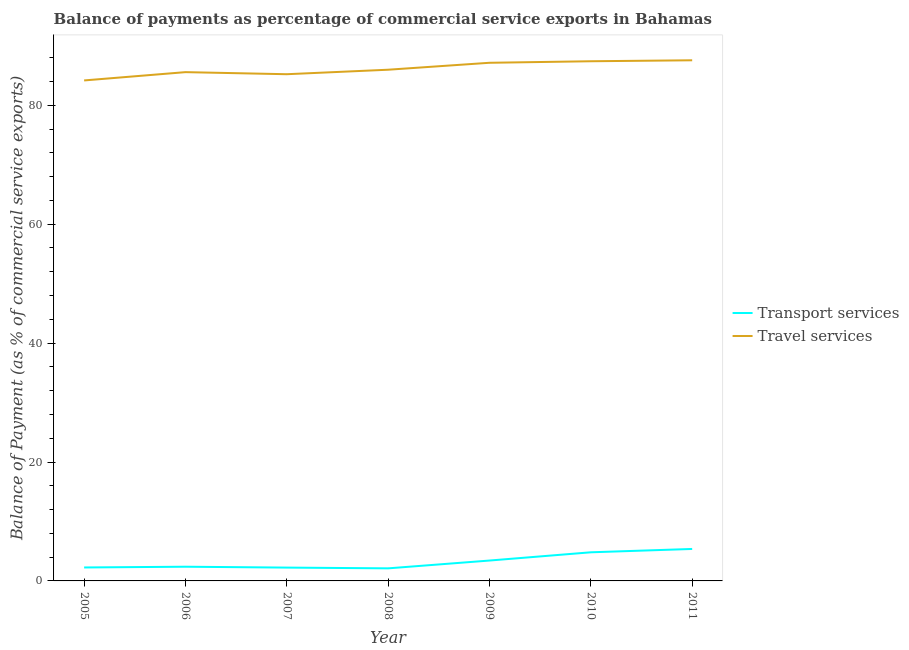Is the number of lines equal to the number of legend labels?
Offer a terse response. Yes. What is the balance of payments of transport services in 2009?
Offer a terse response. 3.43. Across all years, what is the maximum balance of payments of travel services?
Provide a succinct answer. 87.57. Across all years, what is the minimum balance of payments of travel services?
Give a very brief answer. 84.18. What is the total balance of payments of transport services in the graph?
Keep it short and to the point. 22.63. What is the difference between the balance of payments of travel services in 2009 and that in 2010?
Give a very brief answer. -0.26. What is the difference between the balance of payments of transport services in 2006 and the balance of payments of travel services in 2009?
Ensure brevity in your answer.  -84.76. What is the average balance of payments of travel services per year?
Give a very brief answer. 86.15. In the year 2008, what is the difference between the balance of payments of transport services and balance of payments of travel services?
Ensure brevity in your answer.  -83.86. What is the ratio of the balance of payments of transport services in 2008 to that in 2010?
Provide a succinct answer. 0.44. Is the balance of payments of travel services in 2006 less than that in 2007?
Provide a succinct answer. No. Is the difference between the balance of payments of transport services in 2007 and 2009 greater than the difference between the balance of payments of travel services in 2007 and 2009?
Give a very brief answer. Yes. What is the difference between the highest and the second highest balance of payments of transport services?
Provide a succinct answer. 0.56. What is the difference between the highest and the lowest balance of payments of transport services?
Offer a terse response. 3.26. In how many years, is the balance of payments of transport services greater than the average balance of payments of transport services taken over all years?
Provide a short and direct response. 3. Is the sum of the balance of payments of travel services in 2007 and 2008 greater than the maximum balance of payments of transport services across all years?
Your answer should be very brief. Yes. Is the balance of payments of transport services strictly less than the balance of payments of travel services over the years?
Keep it short and to the point. Yes. How many lines are there?
Your answer should be compact. 2. How many years are there in the graph?
Provide a short and direct response. 7. What is the difference between two consecutive major ticks on the Y-axis?
Make the answer very short. 20. Does the graph contain grids?
Ensure brevity in your answer.  No. Where does the legend appear in the graph?
Your answer should be very brief. Center right. How are the legend labels stacked?
Offer a very short reply. Vertical. What is the title of the graph?
Keep it short and to the point. Balance of payments as percentage of commercial service exports in Bahamas. What is the label or title of the X-axis?
Provide a short and direct response. Year. What is the label or title of the Y-axis?
Offer a very short reply. Balance of Payment (as % of commercial service exports). What is the Balance of Payment (as % of commercial service exports) of Transport services in 2005?
Provide a succinct answer. 2.26. What is the Balance of Payment (as % of commercial service exports) of Travel services in 2005?
Offer a terse response. 84.18. What is the Balance of Payment (as % of commercial service exports) of Transport services in 2006?
Your response must be concise. 2.39. What is the Balance of Payment (as % of commercial service exports) of Travel services in 2006?
Offer a very short reply. 85.57. What is the Balance of Payment (as % of commercial service exports) in Transport services in 2007?
Ensure brevity in your answer.  2.24. What is the Balance of Payment (as % of commercial service exports) of Travel services in 2007?
Provide a succinct answer. 85.22. What is the Balance of Payment (as % of commercial service exports) in Transport services in 2008?
Your answer should be very brief. 2.11. What is the Balance of Payment (as % of commercial service exports) in Travel services in 2008?
Offer a terse response. 85.98. What is the Balance of Payment (as % of commercial service exports) of Transport services in 2009?
Offer a terse response. 3.43. What is the Balance of Payment (as % of commercial service exports) of Travel services in 2009?
Give a very brief answer. 87.15. What is the Balance of Payment (as % of commercial service exports) in Transport services in 2010?
Make the answer very short. 4.81. What is the Balance of Payment (as % of commercial service exports) in Travel services in 2010?
Offer a very short reply. 87.4. What is the Balance of Payment (as % of commercial service exports) in Transport services in 2011?
Your answer should be compact. 5.38. What is the Balance of Payment (as % of commercial service exports) of Travel services in 2011?
Your answer should be very brief. 87.57. Across all years, what is the maximum Balance of Payment (as % of commercial service exports) in Transport services?
Your response must be concise. 5.38. Across all years, what is the maximum Balance of Payment (as % of commercial service exports) in Travel services?
Keep it short and to the point. 87.57. Across all years, what is the minimum Balance of Payment (as % of commercial service exports) in Transport services?
Offer a very short reply. 2.11. Across all years, what is the minimum Balance of Payment (as % of commercial service exports) in Travel services?
Provide a succinct answer. 84.18. What is the total Balance of Payment (as % of commercial service exports) in Transport services in the graph?
Offer a very short reply. 22.63. What is the total Balance of Payment (as % of commercial service exports) of Travel services in the graph?
Provide a short and direct response. 603.07. What is the difference between the Balance of Payment (as % of commercial service exports) of Transport services in 2005 and that in 2006?
Make the answer very short. -0.13. What is the difference between the Balance of Payment (as % of commercial service exports) of Travel services in 2005 and that in 2006?
Ensure brevity in your answer.  -1.39. What is the difference between the Balance of Payment (as % of commercial service exports) in Transport services in 2005 and that in 2007?
Offer a terse response. 0.02. What is the difference between the Balance of Payment (as % of commercial service exports) in Travel services in 2005 and that in 2007?
Make the answer very short. -1.05. What is the difference between the Balance of Payment (as % of commercial service exports) of Transport services in 2005 and that in 2008?
Provide a succinct answer. 0.15. What is the difference between the Balance of Payment (as % of commercial service exports) in Travel services in 2005 and that in 2008?
Offer a very short reply. -1.8. What is the difference between the Balance of Payment (as % of commercial service exports) of Transport services in 2005 and that in 2009?
Offer a very short reply. -1.17. What is the difference between the Balance of Payment (as % of commercial service exports) of Travel services in 2005 and that in 2009?
Your answer should be very brief. -2.97. What is the difference between the Balance of Payment (as % of commercial service exports) of Transport services in 2005 and that in 2010?
Your answer should be very brief. -2.55. What is the difference between the Balance of Payment (as % of commercial service exports) in Travel services in 2005 and that in 2010?
Provide a succinct answer. -3.23. What is the difference between the Balance of Payment (as % of commercial service exports) of Transport services in 2005 and that in 2011?
Offer a terse response. -3.12. What is the difference between the Balance of Payment (as % of commercial service exports) of Travel services in 2005 and that in 2011?
Ensure brevity in your answer.  -3.39. What is the difference between the Balance of Payment (as % of commercial service exports) of Transport services in 2006 and that in 2007?
Make the answer very short. 0.15. What is the difference between the Balance of Payment (as % of commercial service exports) of Travel services in 2006 and that in 2007?
Give a very brief answer. 0.35. What is the difference between the Balance of Payment (as % of commercial service exports) of Transport services in 2006 and that in 2008?
Offer a very short reply. 0.27. What is the difference between the Balance of Payment (as % of commercial service exports) in Travel services in 2006 and that in 2008?
Give a very brief answer. -0.41. What is the difference between the Balance of Payment (as % of commercial service exports) in Transport services in 2006 and that in 2009?
Your answer should be very brief. -1.04. What is the difference between the Balance of Payment (as % of commercial service exports) in Travel services in 2006 and that in 2009?
Ensure brevity in your answer.  -1.58. What is the difference between the Balance of Payment (as % of commercial service exports) in Transport services in 2006 and that in 2010?
Keep it short and to the point. -2.42. What is the difference between the Balance of Payment (as % of commercial service exports) of Travel services in 2006 and that in 2010?
Keep it short and to the point. -1.83. What is the difference between the Balance of Payment (as % of commercial service exports) of Transport services in 2006 and that in 2011?
Provide a succinct answer. -2.99. What is the difference between the Balance of Payment (as % of commercial service exports) of Travel services in 2006 and that in 2011?
Provide a succinct answer. -2. What is the difference between the Balance of Payment (as % of commercial service exports) of Transport services in 2007 and that in 2008?
Offer a very short reply. 0.13. What is the difference between the Balance of Payment (as % of commercial service exports) of Travel services in 2007 and that in 2008?
Offer a terse response. -0.76. What is the difference between the Balance of Payment (as % of commercial service exports) in Transport services in 2007 and that in 2009?
Your answer should be very brief. -1.19. What is the difference between the Balance of Payment (as % of commercial service exports) in Travel services in 2007 and that in 2009?
Keep it short and to the point. -1.92. What is the difference between the Balance of Payment (as % of commercial service exports) of Transport services in 2007 and that in 2010?
Offer a very short reply. -2.57. What is the difference between the Balance of Payment (as % of commercial service exports) of Travel services in 2007 and that in 2010?
Ensure brevity in your answer.  -2.18. What is the difference between the Balance of Payment (as % of commercial service exports) of Transport services in 2007 and that in 2011?
Your response must be concise. -3.14. What is the difference between the Balance of Payment (as % of commercial service exports) of Travel services in 2007 and that in 2011?
Your answer should be very brief. -2.34. What is the difference between the Balance of Payment (as % of commercial service exports) of Transport services in 2008 and that in 2009?
Give a very brief answer. -1.31. What is the difference between the Balance of Payment (as % of commercial service exports) of Travel services in 2008 and that in 2009?
Your response must be concise. -1.17. What is the difference between the Balance of Payment (as % of commercial service exports) of Transport services in 2008 and that in 2010?
Your answer should be compact. -2.7. What is the difference between the Balance of Payment (as % of commercial service exports) in Travel services in 2008 and that in 2010?
Give a very brief answer. -1.43. What is the difference between the Balance of Payment (as % of commercial service exports) in Transport services in 2008 and that in 2011?
Your answer should be very brief. -3.26. What is the difference between the Balance of Payment (as % of commercial service exports) of Travel services in 2008 and that in 2011?
Your answer should be compact. -1.59. What is the difference between the Balance of Payment (as % of commercial service exports) of Transport services in 2009 and that in 2010?
Offer a terse response. -1.39. What is the difference between the Balance of Payment (as % of commercial service exports) in Travel services in 2009 and that in 2010?
Offer a terse response. -0.26. What is the difference between the Balance of Payment (as % of commercial service exports) of Transport services in 2009 and that in 2011?
Provide a succinct answer. -1.95. What is the difference between the Balance of Payment (as % of commercial service exports) of Travel services in 2009 and that in 2011?
Your response must be concise. -0.42. What is the difference between the Balance of Payment (as % of commercial service exports) in Transport services in 2010 and that in 2011?
Keep it short and to the point. -0.56. What is the difference between the Balance of Payment (as % of commercial service exports) in Travel services in 2010 and that in 2011?
Offer a very short reply. -0.16. What is the difference between the Balance of Payment (as % of commercial service exports) in Transport services in 2005 and the Balance of Payment (as % of commercial service exports) in Travel services in 2006?
Provide a succinct answer. -83.31. What is the difference between the Balance of Payment (as % of commercial service exports) in Transport services in 2005 and the Balance of Payment (as % of commercial service exports) in Travel services in 2007?
Provide a short and direct response. -82.96. What is the difference between the Balance of Payment (as % of commercial service exports) of Transport services in 2005 and the Balance of Payment (as % of commercial service exports) of Travel services in 2008?
Your answer should be compact. -83.72. What is the difference between the Balance of Payment (as % of commercial service exports) in Transport services in 2005 and the Balance of Payment (as % of commercial service exports) in Travel services in 2009?
Offer a very short reply. -84.88. What is the difference between the Balance of Payment (as % of commercial service exports) of Transport services in 2005 and the Balance of Payment (as % of commercial service exports) of Travel services in 2010?
Provide a succinct answer. -85.14. What is the difference between the Balance of Payment (as % of commercial service exports) of Transport services in 2005 and the Balance of Payment (as % of commercial service exports) of Travel services in 2011?
Make the answer very short. -85.3. What is the difference between the Balance of Payment (as % of commercial service exports) of Transport services in 2006 and the Balance of Payment (as % of commercial service exports) of Travel services in 2007?
Provide a succinct answer. -82.83. What is the difference between the Balance of Payment (as % of commercial service exports) in Transport services in 2006 and the Balance of Payment (as % of commercial service exports) in Travel services in 2008?
Provide a short and direct response. -83.59. What is the difference between the Balance of Payment (as % of commercial service exports) in Transport services in 2006 and the Balance of Payment (as % of commercial service exports) in Travel services in 2009?
Your answer should be compact. -84.76. What is the difference between the Balance of Payment (as % of commercial service exports) in Transport services in 2006 and the Balance of Payment (as % of commercial service exports) in Travel services in 2010?
Provide a short and direct response. -85.02. What is the difference between the Balance of Payment (as % of commercial service exports) of Transport services in 2006 and the Balance of Payment (as % of commercial service exports) of Travel services in 2011?
Give a very brief answer. -85.18. What is the difference between the Balance of Payment (as % of commercial service exports) in Transport services in 2007 and the Balance of Payment (as % of commercial service exports) in Travel services in 2008?
Provide a succinct answer. -83.74. What is the difference between the Balance of Payment (as % of commercial service exports) in Transport services in 2007 and the Balance of Payment (as % of commercial service exports) in Travel services in 2009?
Give a very brief answer. -84.91. What is the difference between the Balance of Payment (as % of commercial service exports) of Transport services in 2007 and the Balance of Payment (as % of commercial service exports) of Travel services in 2010?
Keep it short and to the point. -85.16. What is the difference between the Balance of Payment (as % of commercial service exports) in Transport services in 2007 and the Balance of Payment (as % of commercial service exports) in Travel services in 2011?
Ensure brevity in your answer.  -85.32. What is the difference between the Balance of Payment (as % of commercial service exports) in Transport services in 2008 and the Balance of Payment (as % of commercial service exports) in Travel services in 2009?
Keep it short and to the point. -85.03. What is the difference between the Balance of Payment (as % of commercial service exports) in Transport services in 2008 and the Balance of Payment (as % of commercial service exports) in Travel services in 2010?
Keep it short and to the point. -85.29. What is the difference between the Balance of Payment (as % of commercial service exports) in Transport services in 2008 and the Balance of Payment (as % of commercial service exports) in Travel services in 2011?
Provide a short and direct response. -85.45. What is the difference between the Balance of Payment (as % of commercial service exports) in Transport services in 2009 and the Balance of Payment (as % of commercial service exports) in Travel services in 2010?
Your answer should be very brief. -83.98. What is the difference between the Balance of Payment (as % of commercial service exports) of Transport services in 2009 and the Balance of Payment (as % of commercial service exports) of Travel services in 2011?
Offer a very short reply. -84.14. What is the difference between the Balance of Payment (as % of commercial service exports) of Transport services in 2010 and the Balance of Payment (as % of commercial service exports) of Travel services in 2011?
Provide a short and direct response. -82.75. What is the average Balance of Payment (as % of commercial service exports) in Transport services per year?
Ensure brevity in your answer.  3.23. What is the average Balance of Payment (as % of commercial service exports) in Travel services per year?
Keep it short and to the point. 86.15. In the year 2005, what is the difference between the Balance of Payment (as % of commercial service exports) in Transport services and Balance of Payment (as % of commercial service exports) in Travel services?
Provide a succinct answer. -81.91. In the year 2006, what is the difference between the Balance of Payment (as % of commercial service exports) in Transport services and Balance of Payment (as % of commercial service exports) in Travel services?
Your answer should be very brief. -83.18. In the year 2007, what is the difference between the Balance of Payment (as % of commercial service exports) in Transport services and Balance of Payment (as % of commercial service exports) in Travel services?
Provide a succinct answer. -82.98. In the year 2008, what is the difference between the Balance of Payment (as % of commercial service exports) of Transport services and Balance of Payment (as % of commercial service exports) of Travel services?
Your answer should be compact. -83.86. In the year 2009, what is the difference between the Balance of Payment (as % of commercial service exports) of Transport services and Balance of Payment (as % of commercial service exports) of Travel services?
Make the answer very short. -83.72. In the year 2010, what is the difference between the Balance of Payment (as % of commercial service exports) of Transport services and Balance of Payment (as % of commercial service exports) of Travel services?
Provide a short and direct response. -82.59. In the year 2011, what is the difference between the Balance of Payment (as % of commercial service exports) of Transport services and Balance of Payment (as % of commercial service exports) of Travel services?
Provide a succinct answer. -82.19. What is the ratio of the Balance of Payment (as % of commercial service exports) in Transport services in 2005 to that in 2006?
Make the answer very short. 0.95. What is the ratio of the Balance of Payment (as % of commercial service exports) of Travel services in 2005 to that in 2006?
Offer a very short reply. 0.98. What is the ratio of the Balance of Payment (as % of commercial service exports) in Transport services in 2005 to that in 2007?
Keep it short and to the point. 1.01. What is the ratio of the Balance of Payment (as % of commercial service exports) of Transport services in 2005 to that in 2008?
Make the answer very short. 1.07. What is the ratio of the Balance of Payment (as % of commercial service exports) in Transport services in 2005 to that in 2009?
Ensure brevity in your answer.  0.66. What is the ratio of the Balance of Payment (as % of commercial service exports) of Travel services in 2005 to that in 2009?
Provide a short and direct response. 0.97. What is the ratio of the Balance of Payment (as % of commercial service exports) in Transport services in 2005 to that in 2010?
Your answer should be compact. 0.47. What is the ratio of the Balance of Payment (as % of commercial service exports) in Travel services in 2005 to that in 2010?
Keep it short and to the point. 0.96. What is the ratio of the Balance of Payment (as % of commercial service exports) of Transport services in 2005 to that in 2011?
Your answer should be compact. 0.42. What is the ratio of the Balance of Payment (as % of commercial service exports) in Travel services in 2005 to that in 2011?
Provide a succinct answer. 0.96. What is the ratio of the Balance of Payment (as % of commercial service exports) in Transport services in 2006 to that in 2007?
Make the answer very short. 1.07. What is the ratio of the Balance of Payment (as % of commercial service exports) of Transport services in 2006 to that in 2008?
Make the answer very short. 1.13. What is the ratio of the Balance of Payment (as % of commercial service exports) in Travel services in 2006 to that in 2008?
Your answer should be very brief. 1. What is the ratio of the Balance of Payment (as % of commercial service exports) in Transport services in 2006 to that in 2009?
Make the answer very short. 0.7. What is the ratio of the Balance of Payment (as % of commercial service exports) in Travel services in 2006 to that in 2009?
Your response must be concise. 0.98. What is the ratio of the Balance of Payment (as % of commercial service exports) in Transport services in 2006 to that in 2010?
Ensure brevity in your answer.  0.5. What is the ratio of the Balance of Payment (as % of commercial service exports) of Transport services in 2006 to that in 2011?
Ensure brevity in your answer.  0.44. What is the ratio of the Balance of Payment (as % of commercial service exports) of Travel services in 2006 to that in 2011?
Your answer should be very brief. 0.98. What is the ratio of the Balance of Payment (as % of commercial service exports) in Transport services in 2007 to that in 2008?
Ensure brevity in your answer.  1.06. What is the ratio of the Balance of Payment (as % of commercial service exports) of Transport services in 2007 to that in 2009?
Give a very brief answer. 0.65. What is the ratio of the Balance of Payment (as % of commercial service exports) in Travel services in 2007 to that in 2009?
Offer a terse response. 0.98. What is the ratio of the Balance of Payment (as % of commercial service exports) of Transport services in 2007 to that in 2010?
Your answer should be very brief. 0.47. What is the ratio of the Balance of Payment (as % of commercial service exports) of Transport services in 2007 to that in 2011?
Keep it short and to the point. 0.42. What is the ratio of the Balance of Payment (as % of commercial service exports) of Travel services in 2007 to that in 2011?
Make the answer very short. 0.97. What is the ratio of the Balance of Payment (as % of commercial service exports) of Transport services in 2008 to that in 2009?
Your answer should be very brief. 0.62. What is the ratio of the Balance of Payment (as % of commercial service exports) in Travel services in 2008 to that in 2009?
Offer a very short reply. 0.99. What is the ratio of the Balance of Payment (as % of commercial service exports) in Transport services in 2008 to that in 2010?
Offer a very short reply. 0.44. What is the ratio of the Balance of Payment (as % of commercial service exports) of Travel services in 2008 to that in 2010?
Provide a succinct answer. 0.98. What is the ratio of the Balance of Payment (as % of commercial service exports) of Transport services in 2008 to that in 2011?
Provide a short and direct response. 0.39. What is the ratio of the Balance of Payment (as % of commercial service exports) of Travel services in 2008 to that in 2011?
Make the answer very short. 0.98. What is the ratio of the Balance of Payment (as % of commercial service exports) in Transport services in 2009 to that in 2010?
Ensure brevity in your answer.  0.71. What is the ratio of the Balance of Payment (as % of commercial service exports) of Travel services in 2009 to that in 2010?
Ensure brevity in your answer.  1. What is the ratio of the Balance of Payment (as % of commercial service exports) in Transport services in 2009 to that in 2011?
Give a very brief answer. 0.64. What is the ratio of the Balance of Payment (as % of commercial service exports) in Travel services in 2009 to that in 2011?
Ensure brevity in your answer.  1. What is the ratio of the Balance of Payment (as % of commercial service exports) in Transport services in 2010 to that in 2011?
Offer a very short reply. 0.9. What is the difference between the highest and the second highest Balance of Payment (as % of commercial service exports) of Transport services?
Give a very brief answer. 0.56. What is the difference between the highest and the second highest Balance of Payment (as % of commercial service exports) in Travel services?
Your answer should be very brief. 0.16. What is the difference between the highest and the lowest Balance of Payment (as % of commercial service exports) of Transport services?
Your answer should be very brief. 3.26. What is the difference between the highest and the lowest Balance of Payment (as % of commercial service exports) in Travel services?
Offer a very short reply. 3.39. 